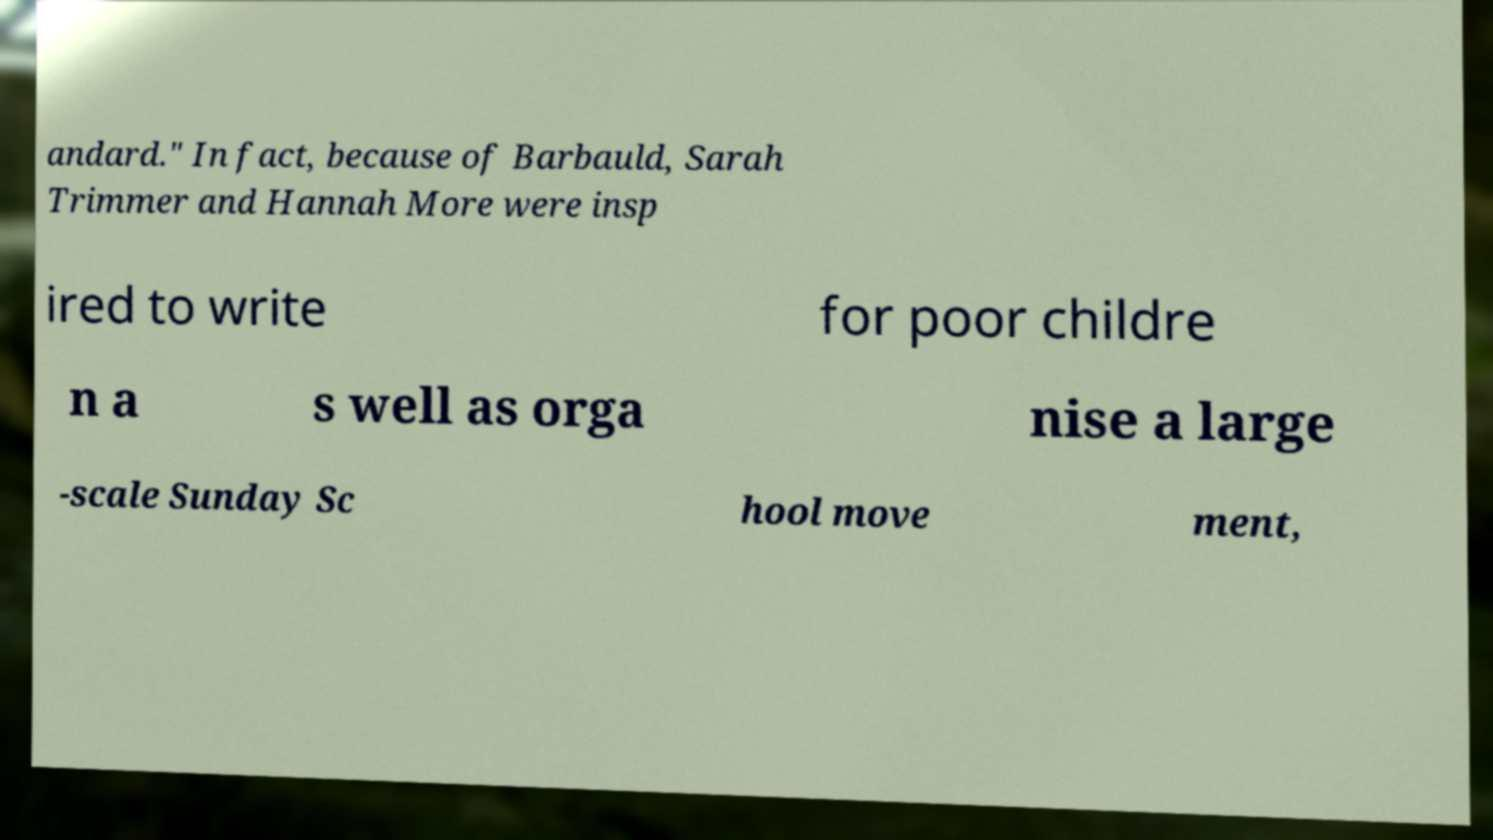I need the written content from this picture converted into text. Can you do that? andard." In fact, because of Barbauld, Sarah Trimmer and Hannah More were insp ired to write for poor childre n a s well as orga nise a large -scale Sunday Sc hool move ment, 